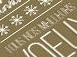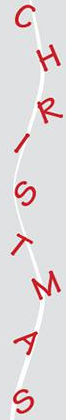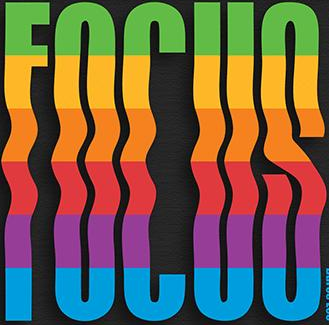What text appears in these images from left to right, separated by a semicolon? #; CHRISTMAS; FOCUS 